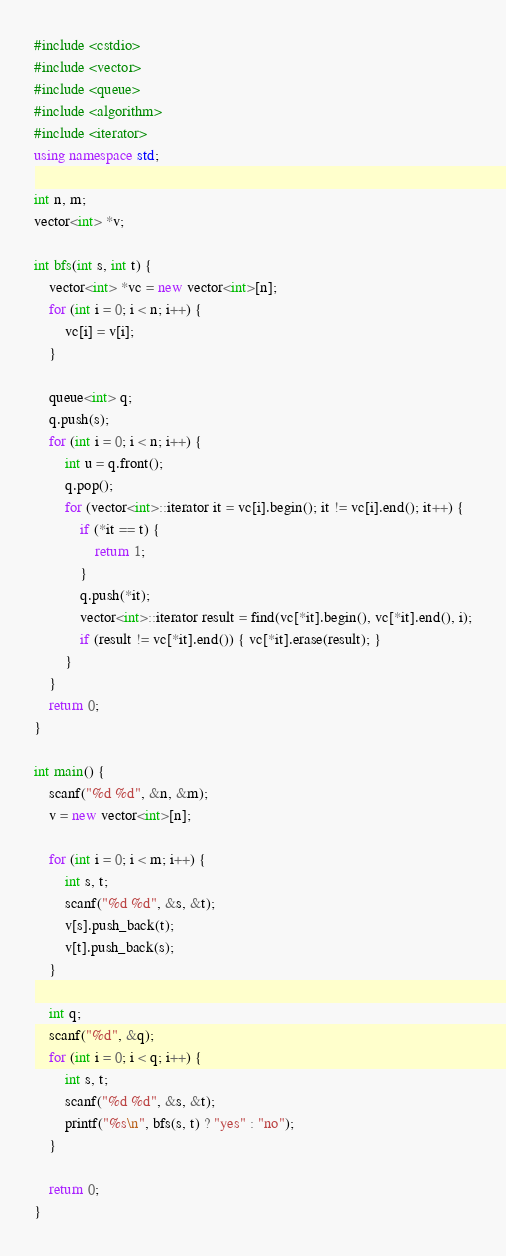Convert code to text. <code><loc_0><loc_0><loc_500><loc_500><_C++_>#include <cstdio>
#include <vector>
#include <queue>
#include <algorithm>
#include <iterator>
using namespace std;

int n, m;
vector<int> *v;

int bfs(int s, int t) {
    vector<int> *vc = new vector<int>[n];
    for (int i = 0; i < n; i++) {
        vc[i] = v[i];
    }

    queue<int> q;
    q.push(s);
    for (int i = 0; i < n; i++) {
        int u = q.front();
        q.pop();
        for (vector<int>::iterator it = vc[i].begin(); it != vc[i].end(); it++) {
            if (*it == t) {
                return 1;
            }
            q.push(*it);
            vector<int>::iterator result = find(vc[*it].begin(), vc[*it].end(), i);
            if (result != vc[*it].end()) { vc[*it].erase(result); }
        }
    }
    return 0;
}

int main() {
    scanf("%d %d", &n, &m);
    v = new vector<int>[n];

    for (int i = 0; i < m; i++) {
        int s, t;
        scanf("%d %d", &s, &t);
        v[s].push_back(t);
        v[t].push_back(s);
    }

    int q;
    scanf("%d", &q);
    for (int i = 0; i < q; i++) {
        int s, t;
        scanf("%d %d", &s, &t);
        printf("%s\n", bfs(s, t) ? "yes" : "no");
    }

    return 0;
}
</code> 